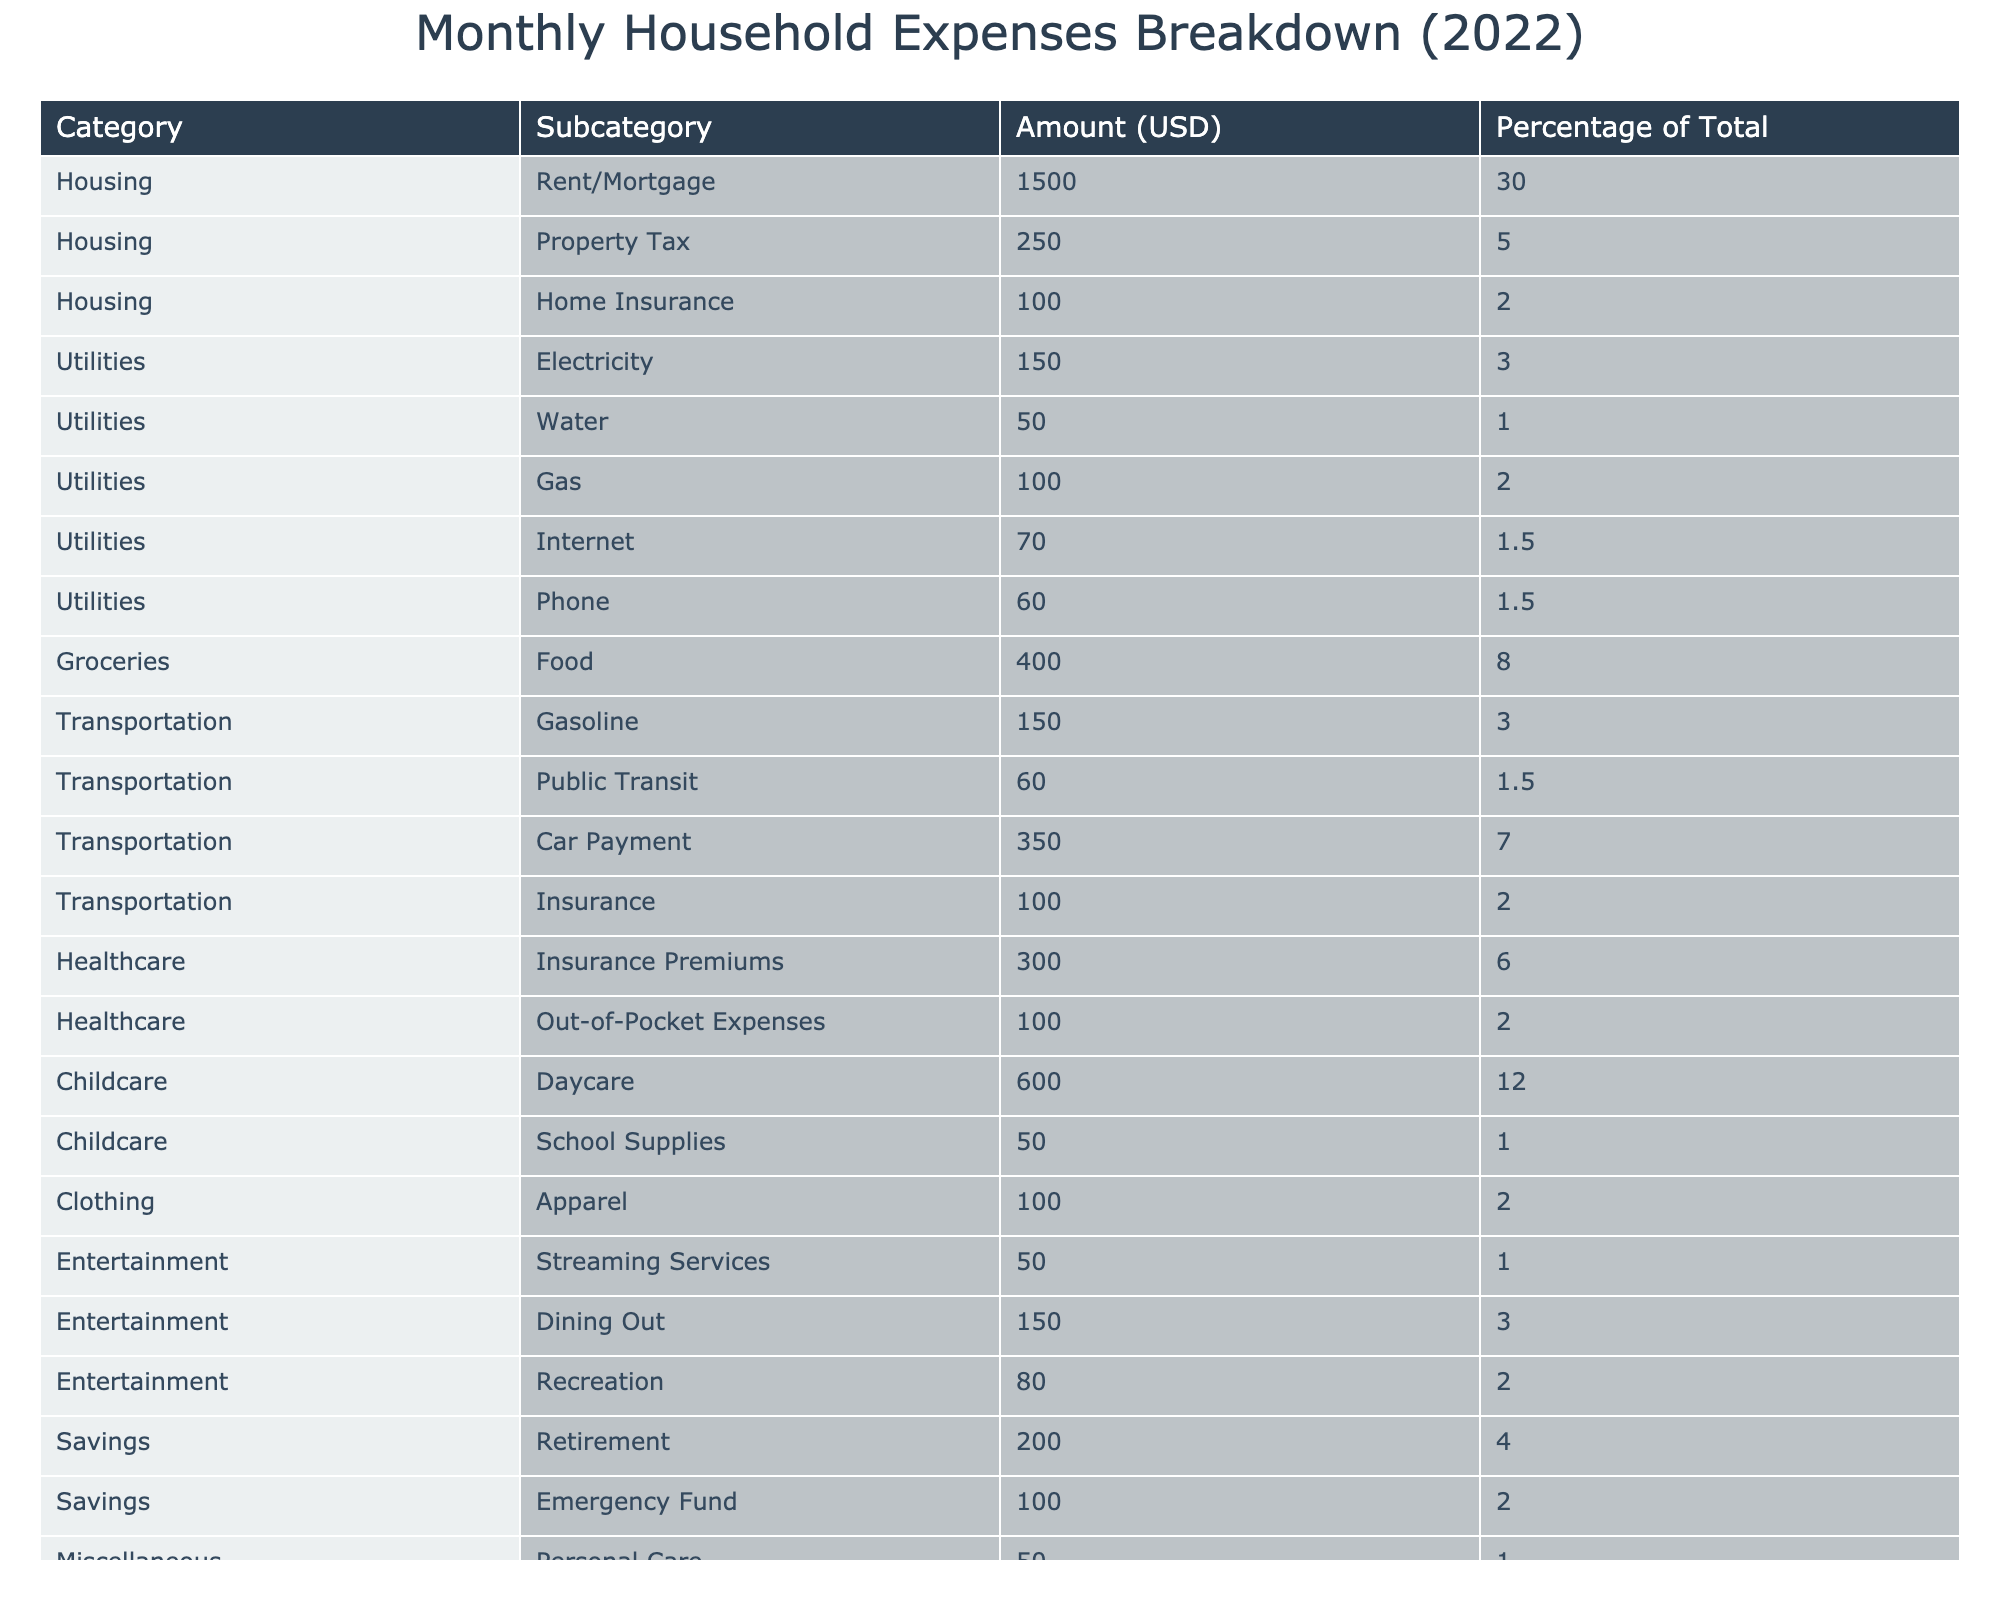What's the total amount spent on Childcare? The total amount spent on Childcare is the sum of Daycare and School Supplies. Daycare is $600 and School Supplies is $50, so $600 + $50 = $650.
Answer: 650 What percentage of the total expenses goes to Housing? The total amount spent on Housing is the sum of Rent/Mortgage, Property Tax, and Home Insurance. This sums up to $1500 + $250 + $100 = $1850. To find the percentage, divide $1850 by total expenses $5000 and multiply by 100, resulting in (1850/5000) * 100 = 37%.
Answer: 37% Is the amount spent on Groceries more than that spent on Transportation? The amount spent on Groceries is $400 and the total for Transportation is Gasoline ($150), Public Transit ($60), Car Payment ($350), and Insurance ($100), totaling $150 + $60 + $350 + $100 = $660. Therefore, $400 is less than $660.
Answer: No Which category has the highest single expense? Looking at the table, Rent/Mortgage under the Housing category has the highest single expense at $1500, as this is larger than any other expense listed in the table.
Answer: Housing (Rent/Mortgage) What is the combined percentage of total expenses spent on Utilities? The percentage for Utilities includes Electricity (3%), Water (1%), Gas (2%), Internet (1.5%), and Phone (1.5%), totaling 3 + 1 + 2 + 1.5 + 1.5 = 9%.
Answer: 9% How much more does the family spend on Entertainment than on Miscellaneous items? The total spent on Entertainment is Streaming Services ($50), Dining Out ($150), and Recreation ($80), which totals $50 + $150 + $80 = $280. For Miscellaneous, Personal Care is $50 and Household Supplies is $75, totaling $50 + $75 = $125. The difference is $280 - $125 = $155.
Answer: 155 What is the total amount allocated to Savings? The amounts for Savings include Retirement ($200) and Emergency Fund ($100). Adding these gives $200 + $100 = $300.
Answer: 300 Is the out-of-pocket expense for Healthcare higher than the property tax? The out-of-pocket expense for Healthcare is $100, which is the same as Property Tax, which is also $100.
Answer: No What can be said about the proportions of expenses on Transportation compared to Groceries? Total spending on Transportation is $660 and on Groceries is $400. To compare, Transportation takes a larger share, 660/5000 = 13.2% versus 400/5000 = 8%. Transportation expenses are significantly higher.
Answer: Transportation is higher than Groceries What category has the lowest expense and how much is it? Looking at the table, the expense with the lowest amount listed is Water, costing $50.
Answer: Water - $50 